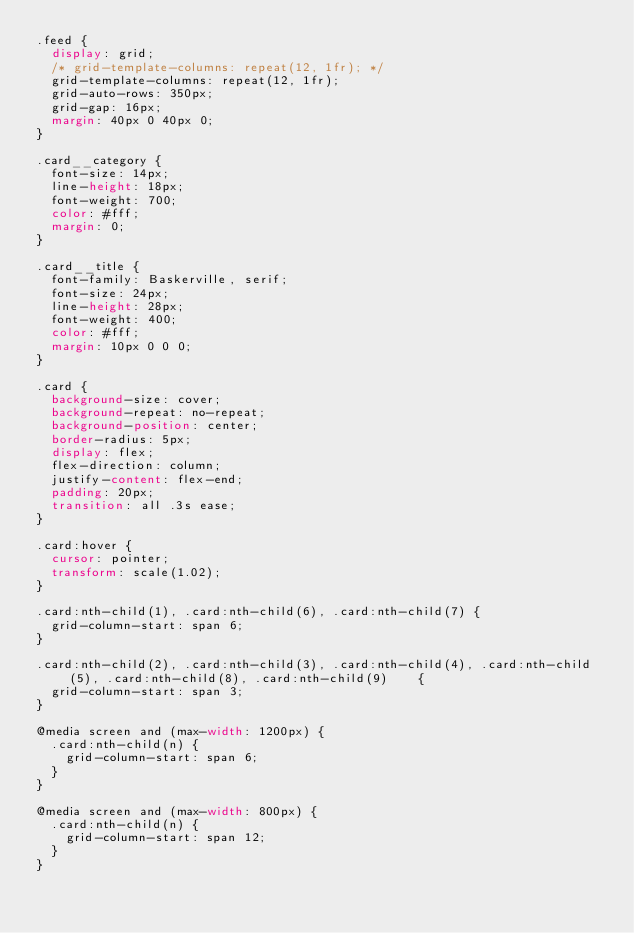Convert code to text. <code><loc_0><loc_0><loc_500><loc_500><_CSS_>.feed {
  display: grid;
  /* grid-template-columns: repeat(12, 1fr); */
  grid-template-columns: repeat(12, 1fr);
  grid-auto-rows: 350px;
  grid-gap: 16px;
  margin: 40px 0 40px 0;
}

.card__category {
  font-size: 14px;
  line-height: 18px;
  font-weight: 700;
  color: #fff;
  margin: 0;
}

.card__title {
  font-family: Baskerville, serif;
  font-size: 24px;
  line-height: 28px;
  font-weight: 400;
  color: #fff;
  margin: 10px 0 0 0;
}

.card {
  background-size: cover;
  background-repeat: no-repeat;
  background-position: center;
  border-radius: 5px;
  display: flex;
  flex-direction: column;
  justify-content: flex-end;
  padding: 20px;
  transition: all .3s ease;
}

.card:hover {
  cursor: pointer;
  transform: scale(1.02);
}

.card:nth-child(1), .card:nth-child(6), .card:nth-child(7) {
  grid-column-start: span 6;
}

.card:nth-child(2), .card:nth-child(3), .card:nth-child(4), .card:nth-child(5), .card:nth-child(8), .card:nth-child(9)    {
  grid-column-start: span 3;
}

@media screen and (max-width: 1200px) {
  .card:nth-child(n) {
    grid-column-start: span 6;
  }
}

@media screen and (max-width: 800px) {
  .card:nth-child(n) {
    grid-column-start: span 12;
  }
}
</code> 